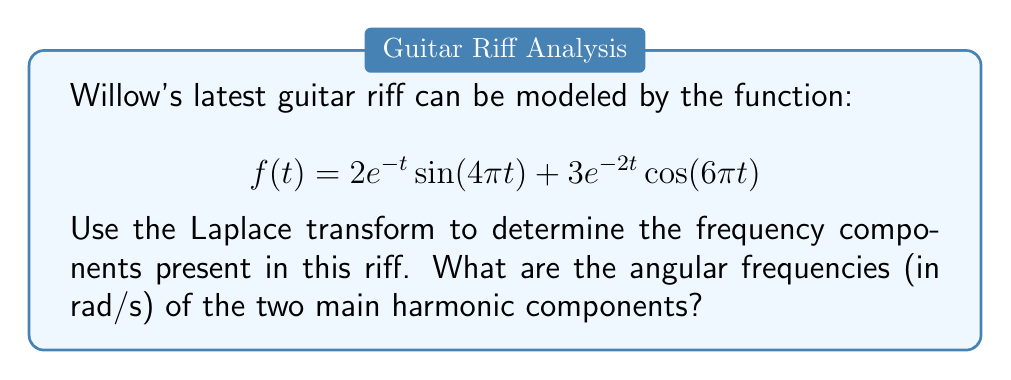Could you help me with this problem? Let's approach this step-by-step:

1) First, we need to calculate the Laplace transform of $f(t)$. Let's do this term by term:

   For $2e^{-t}\sin(4\pi t)$:
   $$\mathcal{L}\{2e^{-t}\sin(4\pi t)\} = \frac{2(4\pi)}{(s+1)^2 + (4\pi)^2}$$

   For $3e^{-2t}\cos(6\pi t)$:
   $$\mathcal{L}\{3e^{-2t}\cos(6\pi t)\} = \frac{3(s+2)}{(s+2)^2 + (6\pi)^2}$$

2) The Laplace transform of $f(t)$ is the sum of these two terms:

   $$F(s) = \frac{2(4\pi)}{(s+1)^2 + (4\pi)^2} + \frac{3(s+2)}{(s+2)^2 + (6\pi)^2}$$

3) The frequency components are determined by the imaginary parts of the poles of $F(s)$. The poles are the values of $s$ that make the denominators zero.

4) For the first term:
   $(s+1)^2 + (4\pi)^2 = 0$
   $s = -1 \pm 4\pi i$

5) For the second term:
   $(s+2)^2 + (6\pi)^2 = 0$
   $s = -2 \pm 6\pi i$

6) The imaginary parts of these poles give us the angular frequencies:
   $\omega_1 = 4\pi$ rad/s
   $\omega_2 = 6\pi$ rad/s

These are the two main harmonic components of Willow's guitar riff.
Answer: $4\pi$ rad/s and $6\pi$ rad/s 